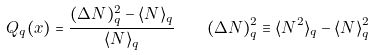Convert formula to latex. <formula><loc_0><loc_0><loc_500><loc_500>Q _ { q } ( x ) = \frac { ( \Delta N ) _ { q } ^ { 2 } - \langle N \rangle _ { q } } { \langle N \rangle _ { q } } \quad ( \Delta N ) _ { q } ^ { 2 } \equiv \langle N ^ { 2 } \rangle _ { q } - \langle N \rangle _ { q } ^ { 2 }</formula> 